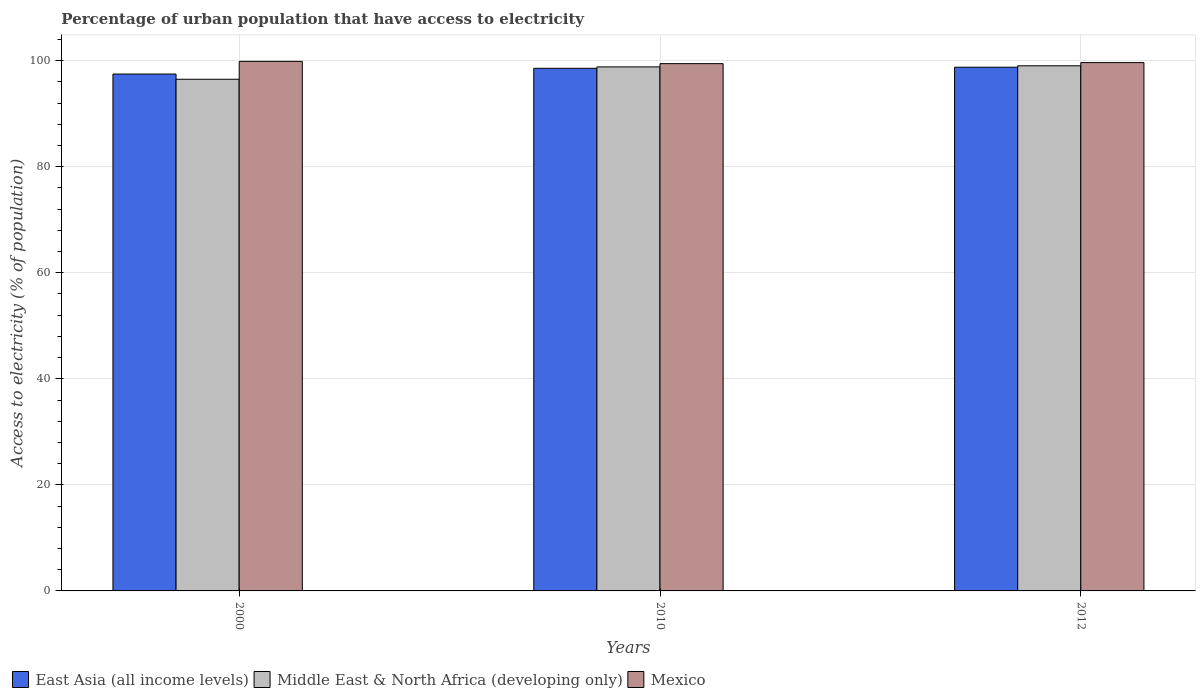How many groups of bars are there?
Keep it short and to the point. 3. Are the number of bars on each tick of the X-axis equal?
Make the answer very short. Yes. What is the label of the 3rd group of bars from the left?
Your answer should be very brief. 2012. In how many cases, is the number of bars for a given year not equal to the number of legend labels?
Your answer should be very brief. 0. What is the percentage of urban population that have access to electricity in Mexico in 2010?
Your answer should be very brief. 99.43. Across all years, what is the maximum percentage of urban population that have access to electricity in East Asia (all income levels)?
Give a very brief answer. 98.76. Across all years, what is the minimum percentage of urban population that have access to electricity in Middle East & North Africa (developing only)?
Provide a short and direct response. 96.48. What is the total percentage of urban population that have access to electricity in Middle East & North Africa (developing only) in the graph?
Offer a very short reply. 294.32. What is the difference between the percentage of urban population that have access to electricity in Middle East & North Africa (developing only) in 2010 and that in 2012?
Offer a terse response. -0.2. What is the difference between the percentage of urban population that have access to electricity in Mexico in 2000 and the percentage of urban population that have access to electricity in Middle East & North Africa (developing only) in 2012?
Keep it short and to the point. 0.84. What is the average percentage of urban population that have access to electricity in East Asia (all income levels) per year?
Offer a very short reply. 98.26. In the year 2000, what is the difference between the percentage of urban population that have access to electricity in Middle East & North Africa (developing only) and percentage of urban population that have access to electricity in East Asia (all income levels)?
Your answer should be compact. -0.99. What is the ratio of the percentage of urban population that have access to electricity in East Asia (all income levels) in 2000 to that in 2010?
Give a very brief answer. 0.99. Is the percentage of urban population that have access to electricity in East Asia (all income levels) in 2010 less than that in 2012?
Make the answer very short. Yes. Is the difference between the percentage of urban population that have access to electricity in Middle East & North Africa (developing only) in 2000 and 2012 greater than the difference between the percentage of urban population that have access to electricity in East Asia (all income levels) in 2000 and 2012?
Your answer should be very brief. No. What is the difference between the highest and the second highest percentage of urban population that have access to electricity in East Asia (all income levels)?
Offer a terse response. 0.21. What is the difference between the highest and the lowest percentage of urban population that have access to electricity in Mexico?
Give a very brief answer. 0.43. In how many years, is the percentage of urban population that have access to electricity in Middle East & North Africa (developing only) greater than the average percentage of urban population that have access to electricity in Middle East & North Africa (developing only) taken over all years?
Ensure brevity in your answer.  2. What does the 3rd bar from the right in 2000 represents?
Offer a very short reply. East Asia (all income levels). Are all the bars in the graph horizontal?
Make the answer very short. No. Does the graph contain any zero values?
Your answer should be very brief. No. Does the graph contain grids?
Provide a succinct answer. Yes. Where does the legend appear in the graph?
Your answer should be very brief. Bottom left. What is the title of the graph?
Make the answer very short. Percentage of urban population that have access to electricity. What is the label or title of the X-axis?
Offer a terse response. Years. What is the label or title of the Y-axis?
Make the answer very short. Access to electricity (% of population). What is the Access to electricity (% of population) in East Asia (all income levels) in 2000?
Offer a terse response. 97.47. What is the Access to electricity (% of population) of Middle East & North Africa (developing only) in 2000?
Your answer should be very brief. 96.48. What is the Access to electricity (% of population) of Mexico in 2000?
Give a very brief answer. 99.86. What is the Access to electricity (% of population) in East Asia (all income levels) in 2010?
Give a very brief answer. 98.55. What is the Access to electricity (% of population) of Middle East & North Africa (developing only) in 2010?
Ensure brevity in your answer.  98.82. What is the Access to electricity (% of population) in Mexico in 2010?
Offer a very short reply. 99.43. What is the Access to electricity (% of population) of East Asia (all income levels) in 2012?
Your response must be concise. 98.76. What is the Access to electricity (% of population) in Middle East & North Africa (developing only) in 2012?
Provide a succinct answer. 99.02. What is the Access to electricity (% of population) in Mexico in 2012?
Offer a terse response. 99.62. Across all years, what is the maximum Access to electricity (% of population) in East Asia (all income levels)?
Your response must be concise. 98.76. Across all years, what is the maximum Access to electricity (% of population) of Middle East & North Africa (developing only)?
Offer a very short reply. 99.02. Across all years, what is the maximum Access to electricity (% of population) of Mexico?
Offer a terse response. 99.86. Across all years, what is the minimum Access to electricity (% of population) of East Asia (all income levels)?
Provide a succinct answer. 97.47. Across all years, what is the minimum Access to electricity (% of population) of Middle East & North Africa (developing only)?
Keep it short and to the point. 96.48. Across all years, what is the minimum Access to electricity (% of population) in Mexico?
Keep it short and to the point. 99.43. What is the total Access to electricity (% of population) in East Asia (all income levels) in the graph?
Provide a succinct answer. 294.77. What is the total Access to electricity (% of population) of Middle East & North Africa (developing only) in the graph?
Your answer should be compact. 294.32. What is the total Access to electricity (% of population) in Mexico in the graph?
Make the answer very short. 298.91. What is the difference between the Access to electricity (% of population) of East Asia (all income levels) in 2000 and that in 2010?
Offer a terse response. -1.08. What is the difference between the Access to electricity (% of population) in Middle East & North Africa (developing only) in 2000 and that in 2010?
Provide a succinct answer. -2.33. What is the difference between the Access to electricity (% of population) in Mexico in 2000 and that in 2010?
Give a very brief answer. 0.43. What is the difference between the Access to electricity (% of population) in East Asia (all income levels) in 2000 and that in 2012?
Your response must be concise. -1.29. What is the difference between the Access to electricity (% of population) of Middle East & North Africa (developing only) in 2000 and that in 2012?
Your answer should be very brief. -2.54. What is the difference between the Access to electricity (% of population) in Mexico in 2000 and that in 2012?
Your answer should be compact. 0.24. What is the difference between the Access to electricity (% of population) in East Asia (all income levels) in 2010 and that in 2012?
Provide a succinct answer. -0.21. What is the difference between the Access to electricity (% of population) of Middle East & North Africa (developing only) in 2010 and that in 2012?
Keep it short and to the point. -0.2. What is the difference between the Access to electricity (% of population) of Mexico in 2010 and that in 2012?
Offer a terse response. -0.2. What is the difference between the Access to electricity (% of population) of East Asia (all income levels) in 2000 and the Access to electricity (% of population) of Middle East & North Africa (developing only) in 2010?
Offer a terse response. -1.35. What is the difference between the Access to electricity (% of population) of East Asia (all income levels) in 2000 and the Access to electricity (% of population) of Mexico in 2010?
Provide a succinct answer. -1.96. What is the difference between the Access to electricity (% of population) of Middle East & North Africa (developing only) in 2000 and the Access to electricity (% of population) of Mexico in 2010?
Make the answer very short. -2.94. What is the difference between the Access to electricity (% of population) in East Asia (all income levels) in 2000 and the Access to electricity (% of population) in Middle East & North Africa (developing only) in 2012?
Keep it short and to the point. -1.55. What is the difference between the Access to electricity (% of population) in East Asia (all income levels) in 2000 and the Access to electricity (% of population) in Mexico in 2012?
Provide a short and direct response. -2.15. What is the difference between the Access to electricity (% of population) in Middle East & North Africa (developing only) in 2000 and the Access to electricity (% of population) in Mexico in 2012?
Ensure brevity in your answer.  -3.14. What is the difference between the Access to electricity (% of population) of East Asia (all income levels) in 2010 and the Access to electricity (% of population) of Middle East & North Africa (developing only) in 2012?
Keep it short and to the point. -0.47. What is the difference between the Access to electricity (% of population) of East Asia (all income levels) in 2010 and the Access to electricity (% of population) of Mexico in 2012?
Give a very brief answer. -1.07. What is the difference between the Access to electricity (% of population) in Middle East & North Africa (developing only) in 2010 and the Access to electricity (% of population) in Mexico in 2012?
Keep it short and to the point. -0.81. What is the average Access to electricity (% of population) of East Asia (all income levels) per year?
Make the answer very short. 98.26. What is the average Access to electricity (% of population) of Middle East & North Africa (developing only) per year?
Provide a short and direct response. 98.11. What is the average Access to electricity (% of population) of Mexico per year?
Your response must be concise. 99.64. In the year 2000, what is the difference between the Access to electricity (% of population) in East Asia (all income levels) and Access to electricity (% of population) in Middle East & North Africa (developing only)?
Make the answer very short. 0.99. In the year 2000, what is the difference between the Access to electricity (% of population) of East Asia (all income levels) and Access to electricity (% of population) of Mexico?
Ensure brevity in your answer.  -2.39. In the year 2000, what is the difference between the Access to electricity (% of population) in Middle East & North Africa (developing only) and Access to electricity (% of population) in Mexico?
Your answer should be compact. -3.38. In the year 2010, what is the difference between the Access to electricity (% of population) of East Asia (all income levels) and Access to electricity (% of population) of Middle East & North Africa (developing only)?
Offer a very short reply. -0.27. In the year 2010, what is the difference between the Access to electricity (% of population) in East Asia (all income levels) and Access to electricity (% of population) in Mexico?
Keep it short and to the point. -0.88. In the year 2010, what is the difference between the Access to electricity (% of population) in Middle East & North Africa (developing only) and Access to electricity (% of population) in Mexico?
Offer a very short reply. -0.61. In the year 2012, what is the difference between the Access to electricity (% of population) of East Asia (all income levels) and Access to electricity (% of population) of Middle East & North Africa (developing only)?
Keep it short and to the point. -0.27. In the year 2012, what is the difference between the Access to electricity (% of population) of East Asia (all income levels) and Access to electricity (% of population) of Mexico?
Offer a terse response. -0.87. In the year 2012, what is the difference between the Access to electricity (% of population) of Middle East & North Africa (developing only) and Access to electricity (% of population) of Mexico?
Offer a very short reply. -0.6. What is the ratio of the Access to electricity (% of population) in Middle East & North Africa (developing only) in 2000 to that in 2010?
Your answer should be compact. 0.98. What is the ratio of the Access to electricity (% of population) of Mexico in 2000 to that in 2010?
Your answer should be very brief. 1. What is the ratio of the Access to electricity (% of population) of Middle East & North Africa (developing only) in 2000 to that in 2012?
Keep it short and to the point. 0.97. What is the difference between the highest and the second highest Access to electricity (% of population) in East Asia (all income levels)?
Provide a short and direct response. 0.21. What is the difference between the highest and the second highest Access to electricity (% of population) in Middle East & North Africa (developing only)?
Make the answer very short. 0.2. What is the difference between the highest and the second highest Access to electricity (% of population) in Mexico?
Provide a succinct answer. 0.24. What is the difference between the highest and the lowest Access to electricity (% of population) in East Asia (all income levels)?
Your response must be concise. 1.29. What is the difference between the highest and the lowest Access to electricity (% of population) of Middle East & North Africa (developing only)?
Offer a terse response. 2.54. What is the difference between the highest and the lowest Access to electricity (% of population) of Mexico?
Provide a short and direct response. 0.43. 